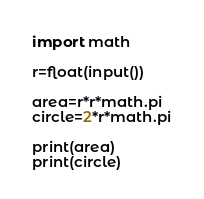Convert code to text. <code><loc_0><loc_0><loc_500><loc_500><_Python_>import math

r=float(input())

area=r*r*math.pi
circle=2*r*math.pi

print(area)
print(circle)
</code> 